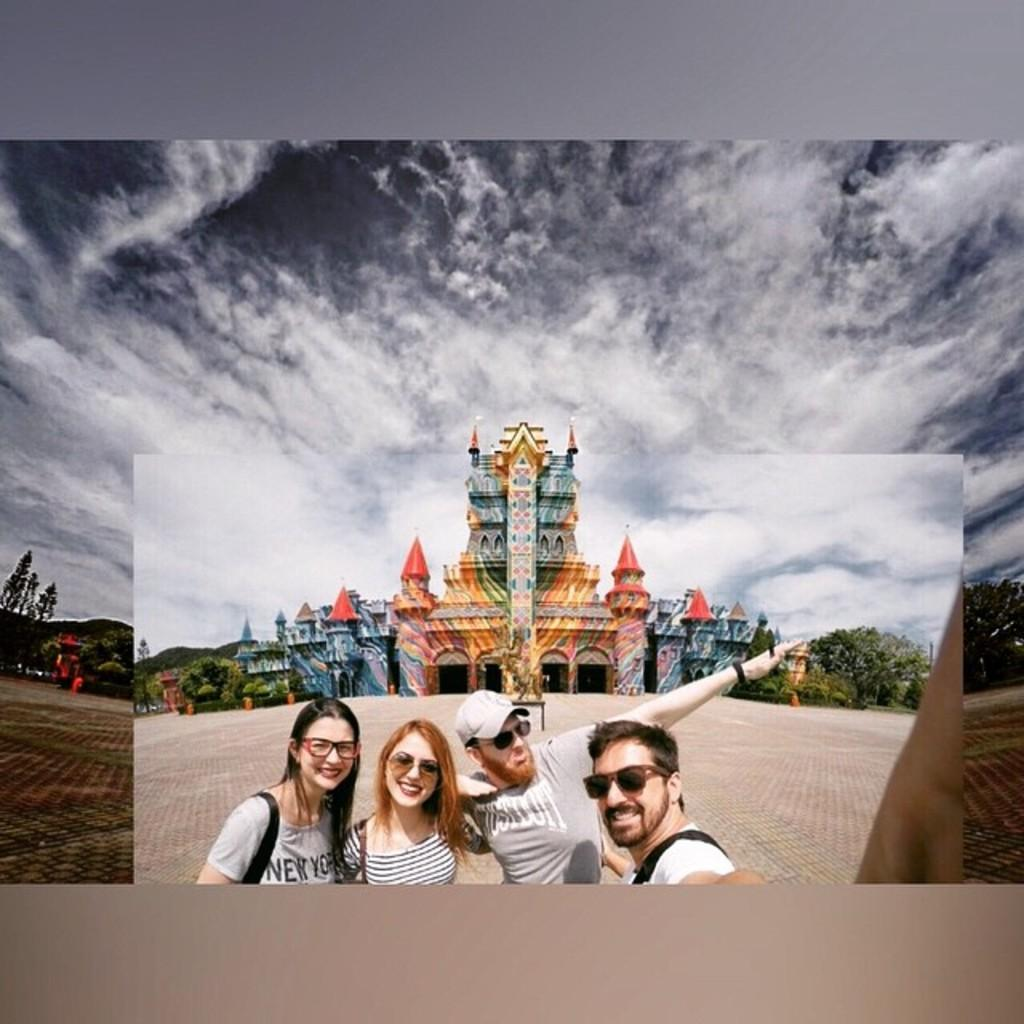How many people are in the image? There are four persons in the center of the image. What is visible in the background of the image? There is a castle and trees in the background of the image. What is visible at the top of the image? The sky is visible at the top of the image. How many hands does the sister have in the image? There is no mention of a sister or hands in the image, so we cannot answer that question. 